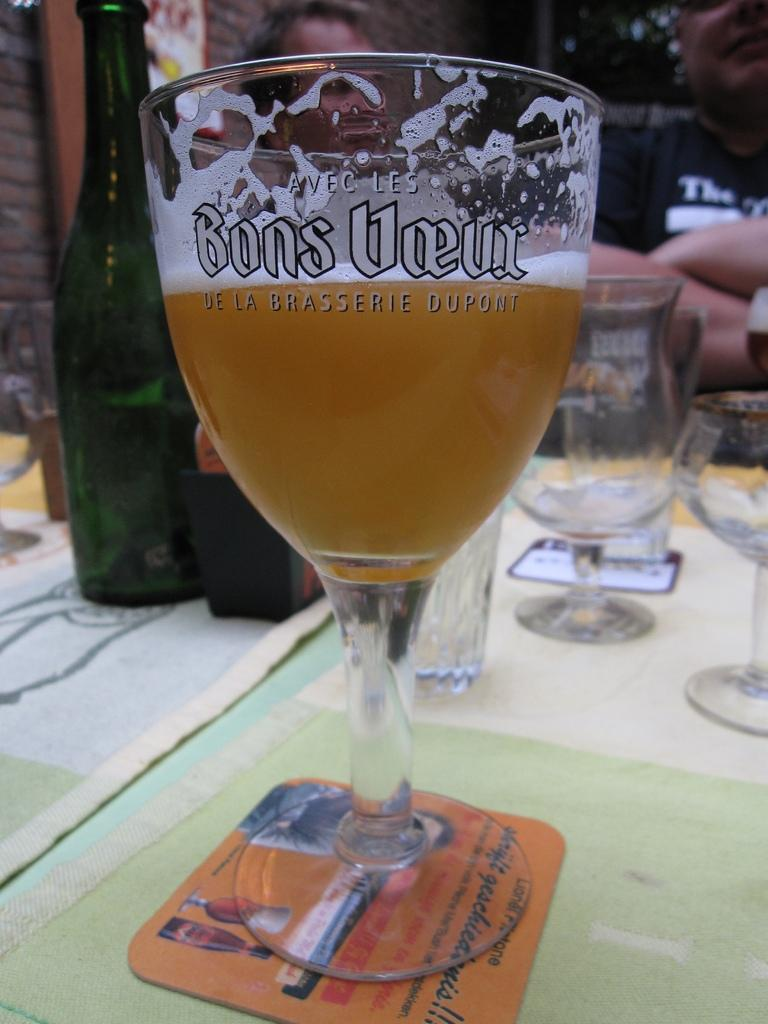<image>
Provide a brief description of the given image. A half full glass of beer in a glass etched with Bons Voeur sits on a coaster. 